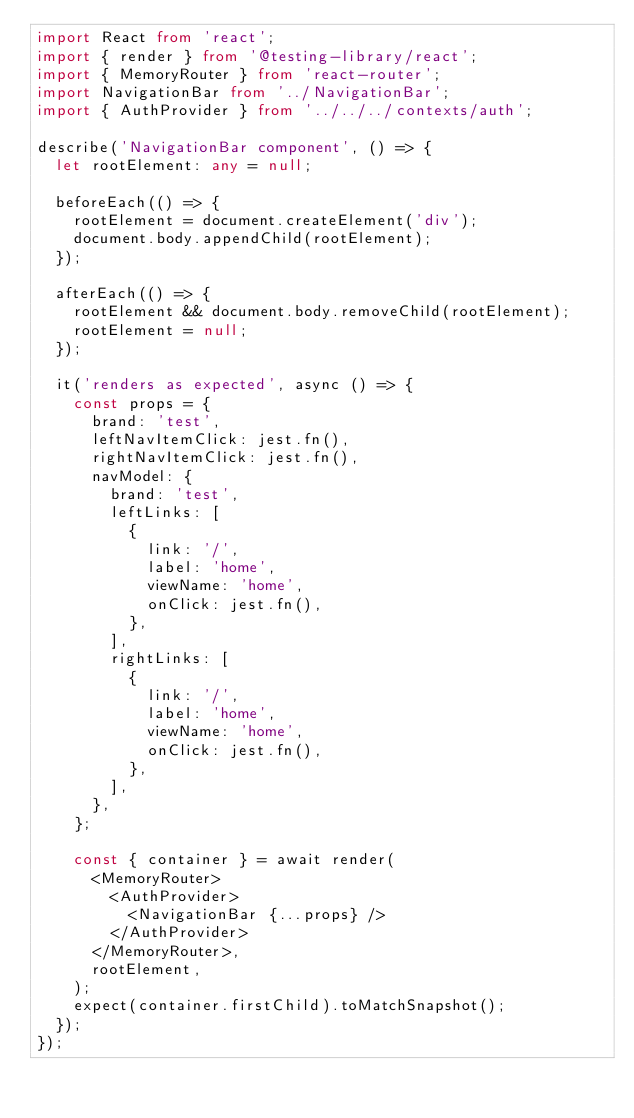<code> <loc_0><loc_0><loc_500><loc_500><_TypeScript_>import React from 'react';
import { render } from '@testing-library/react';
import { MemoryRouter } from 'react-router';
import NavigationBar from '../NavigationBar';
import { AuthProvider } from '../../../contexts/auth';

describe('NavigationBar component', () => {
  let rootElement: any = null;

  beforeEach(() => {
    rootElement = document.createElement('div');
    document.body.appendChild(rootElement);
  });

  afterEach(() => {
    rootElement && document.body.removeChild(rootElement);
    rootElement = null;
  });

  it('renders as expected', async () => {
    const props = {
      brand: 'test',
      leftNavItemClick: jest.fn(),
      rightNavItemClick: jest.fn(),
      navModel: {
        brand: 'test',
        leftLinks: [
          {
            link: '/',
            label: 'home',
            viewName: 'home',
            onClick: jest.fn(),
          },
        ],
        rightLinks: [
          {
            link: '/',
            label: 'home',
            viewName: 'home',
            onClick: jest.fn(),
          },
        ],
      },
    };

    const { container } = await render(
      <MemoryRouter>
        <AuthProvider>
          <NavigationBar {...props} />
        </AuthProvider>
      </MemoryRouter>,
      rootElement,
    );
    expect(container.firstChild).toMatchSnapshot();
  });
});
</code> 